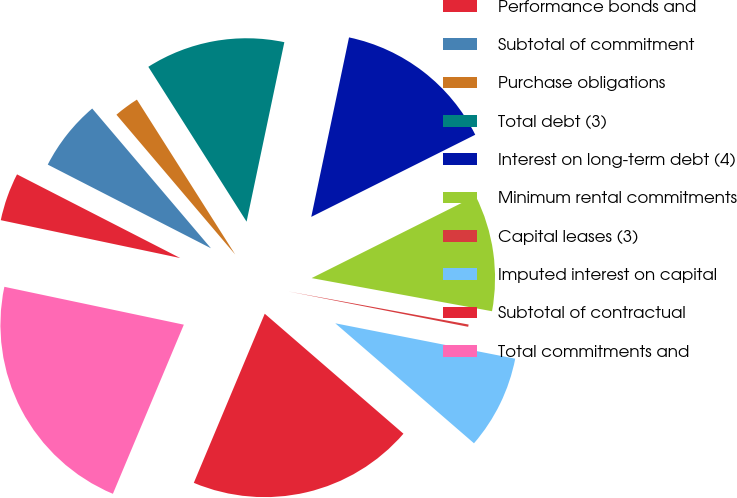Convert chart to OTSL. <chart><loc_0><loc_0><loc_500><loc_500><pie_chart><fcel>Performance bonds and<fcel>Subtotal of commitment<fcel>Purchase obligations<fcel>Total debt (3)<fcel>Interest on long-term debt (4)<fcel>Minimum rental commitments<fcel>Capital leases (3)<fcel>Imputed interest on capital<fcel>Subtotal of contractual<fcel>Total commitments and<nl><fcel>4.23%<fcel>6.25%<fcel>2.21%<fcel>12.3%<fcel>14.31%<fcel>10.28%<fcel>0.2%<fcel>8.26%<fcel>19.97%<fcel>21.99%<nl></chart> 